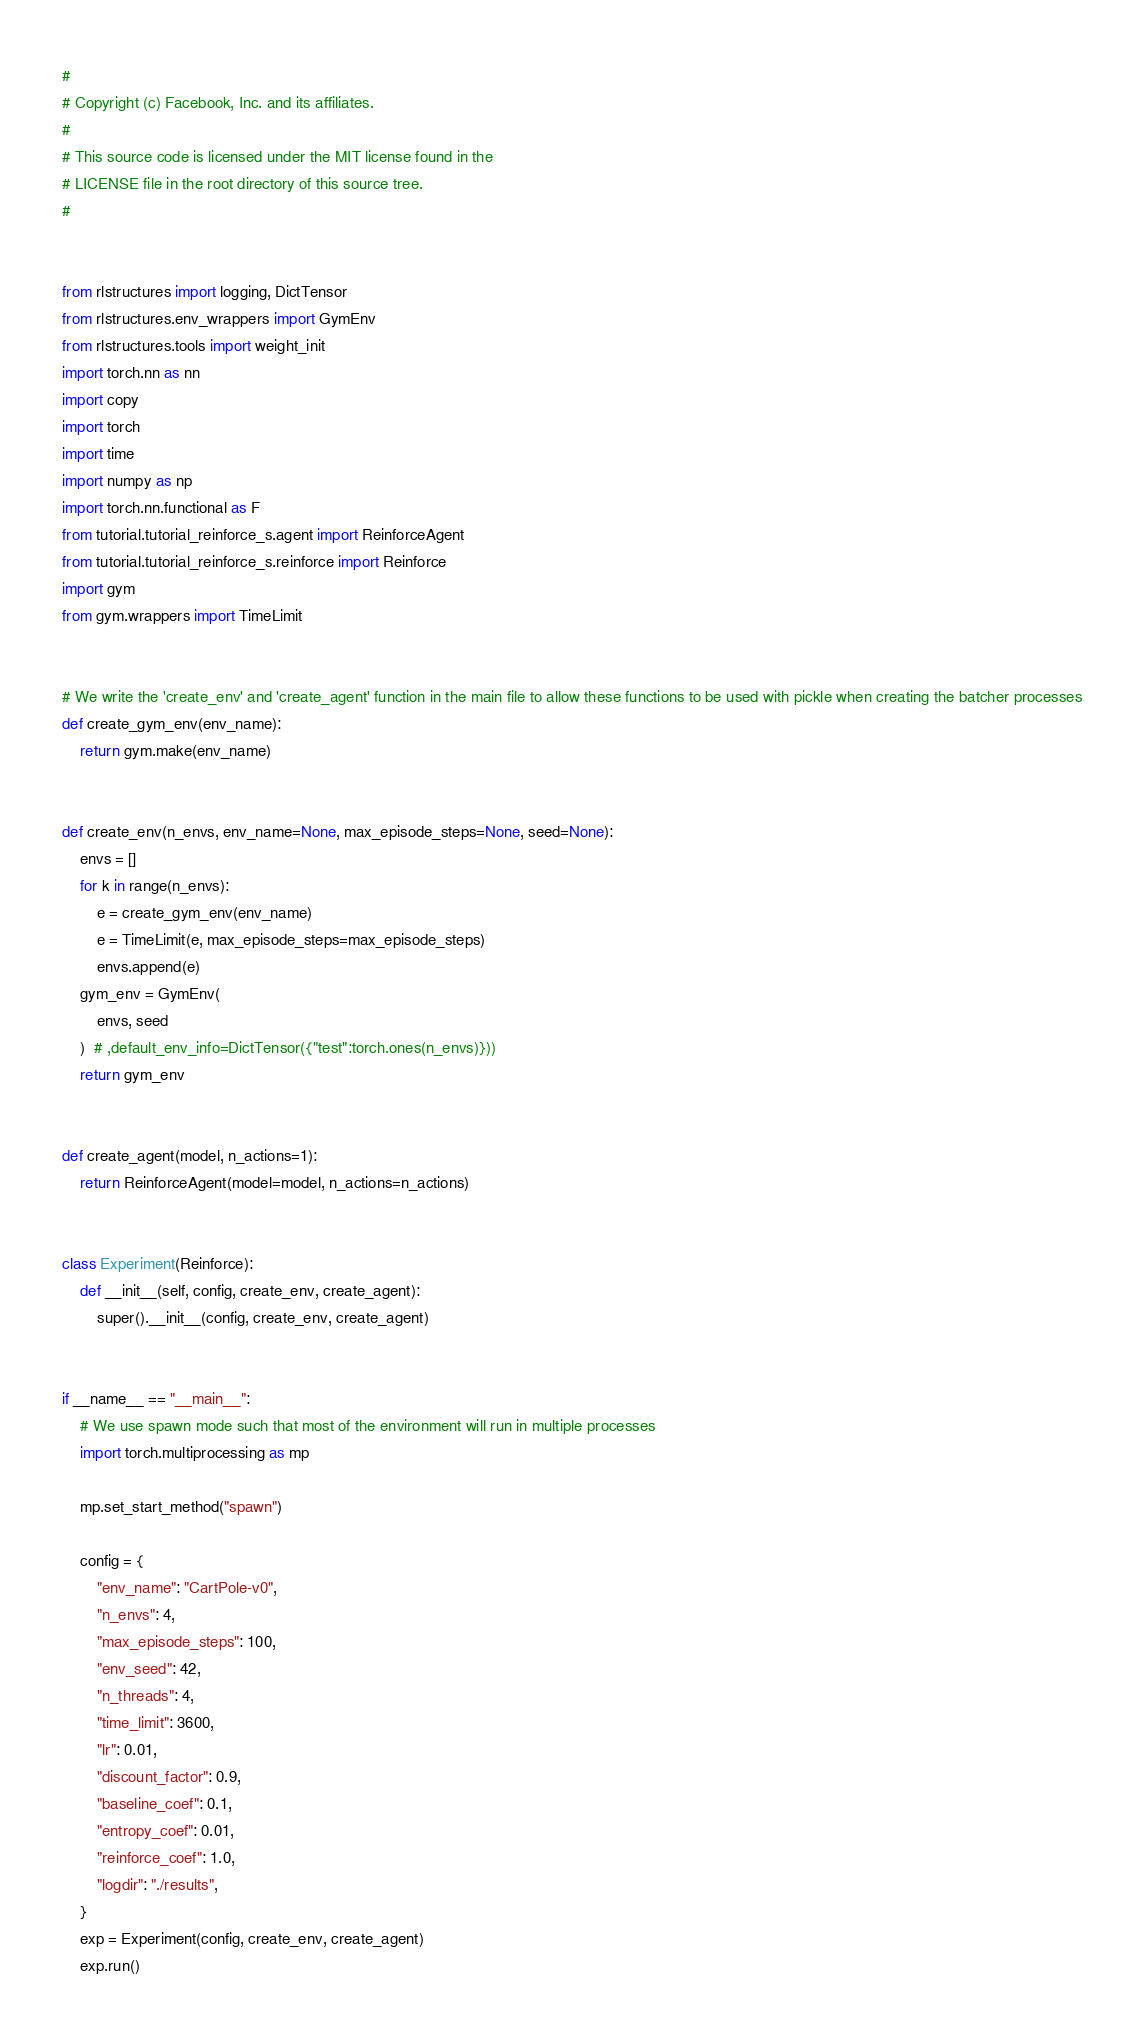<code> <loc_0><loc_0><loc_500><loc_500><_Python_>#
# Copyright (c) Facebook, Inc. and its affiliates.
#
# This source code is licensed under the MIT license found in the
# LICENSE file in the root directory of this source tree.
#


from rlstructures import logging, DictTensor
from rlstructures.env_wrappers import GymEnv
from rlstructures.tools import weight_init
import torch.nn as nn
import copy
import torch
import time
import numpy as np
import torch.nn.functional as F
from tutorial.tutorial_reinforce_s.agent import ReinforceAgent
from tutorial.tutorial_reinforce_s.reinforce import Reinforce
import gym
from gym.wrappers import TimeLimit


# We write the 'create_env' and 'create_agent' function in the main file to allow these functions to be used with pickle when creating the batcher processes
def create_gym_env(env_name):
    return gym.make(env_name)


def create_env(n_envs, env_name=None, max_episode_steps=None, seed=None):
    envs = []
    for k in range(n_envs):
        e = create_gym_env(env_name)
        e = TimeLimit(e, max_episode_steps=max_episode_steps)
        envs.append(e)
    gym_env = GymEnv(
        envs, seed
    )  # ,default_env_info=DictTensor({"test":torch.ones(n_envs)}))
    return gym_env


def create_agent(model, n_actions=1):
    return ReinforceAgent(model=model, n_actions=n_actions)


class Experiment(Reinforce):
    def __init__(self, config, create_env, create_agent):
        super().__init__(config, create_env, create_agent)


if __name__ == "__main__":
    # We use spawn mode such that most of the environment will run in multiple processes
    import torch.multiprocessing as mp

    mp.set_start_method("spawn")

    config = {
        "env_name": "CartPole-v0",
        "n_envs": 4,
        "max_episode_steps": 100,
        "env_seed": 42,
        "n_threads": 4,
        "time_limit": 3600,
        "lr": 0.01,
        "discount_factor": 0.9,
        "baseline_coef": 0.1,
        "entropy_coef": 0.01,
        "reinforce_coef": 1.0,
        "logdir": "./results",
    }
    exp = Experiment(config, create_env, create_agent)
    exp.run()
</code> 